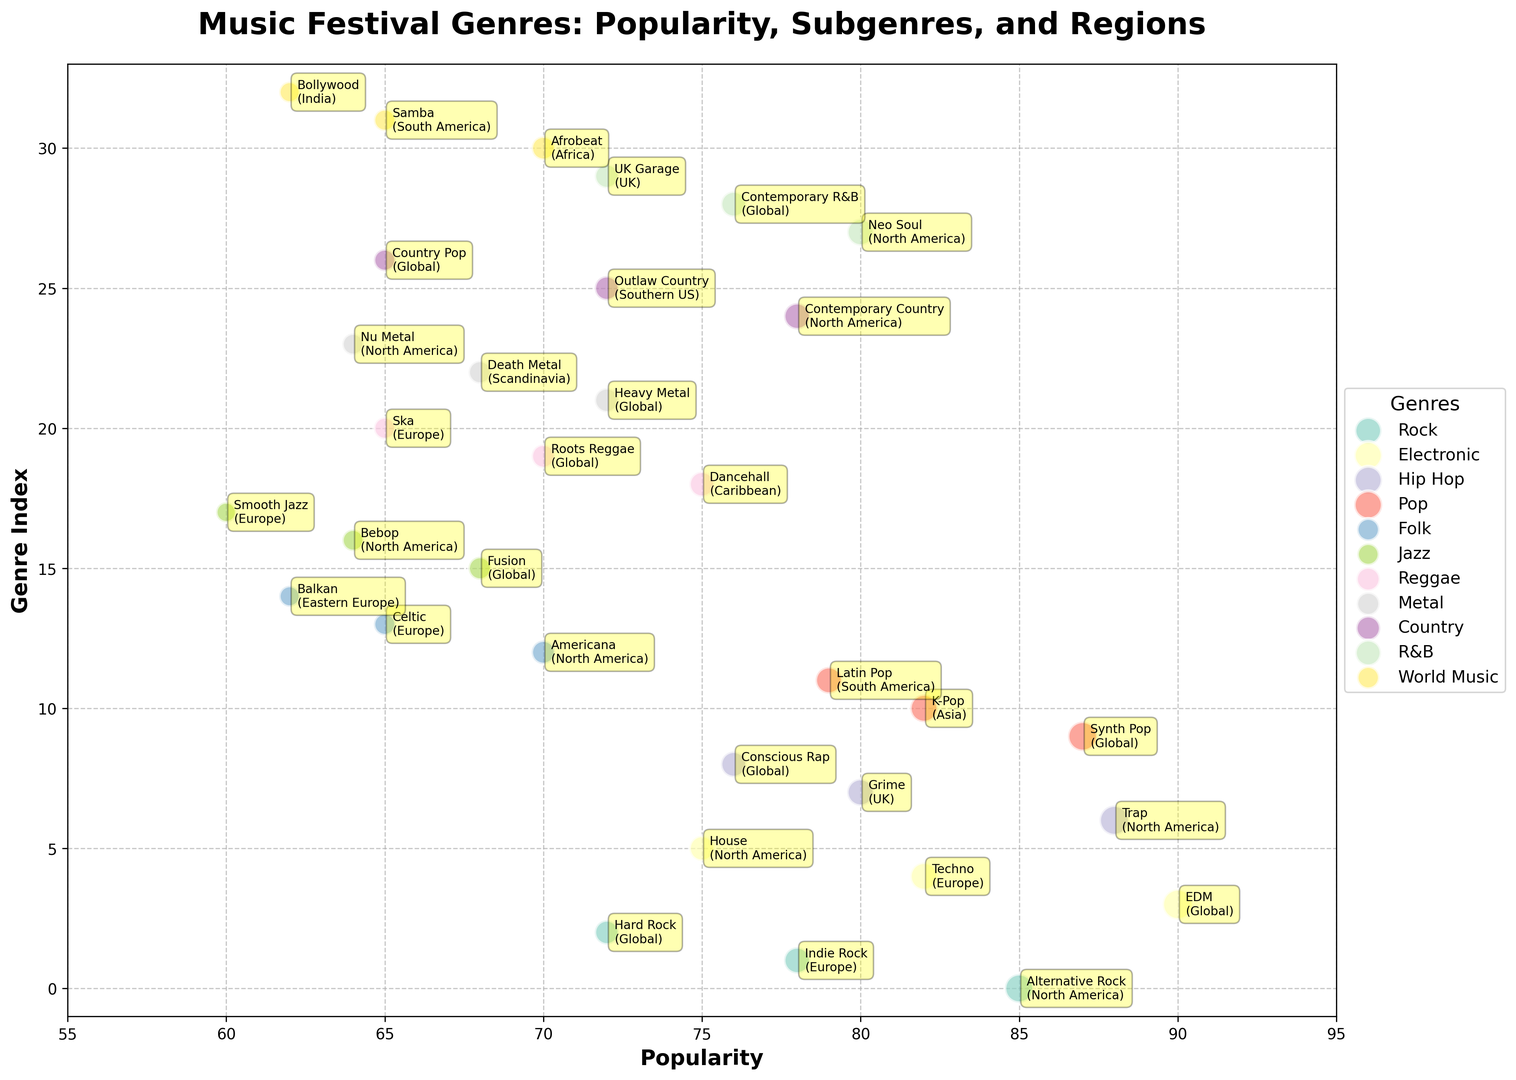Which genre has the highest popularity at festivals? The figure shows several genres with bubbles of varying sizes on the x-axis representing popularity. The highest value for popularity is represented by the largest bubble located farthest to the right. In this case, Electronic music with EDM subgenre has the highest popularity at 90.
Answer: Electronic How does the popularity of Grime (UK) compare with Techno (Europe)? The figure shows different bubbles for subgenres within each genre. Grime has a popularity of 80, while Techno has a popularity of 82. Therefore, Techno is slightly more popular than Grime.
Answer: Techno is more popular How many genres have a popularity above 80? By counting the bubbles on the x-axis that have values greater than 80, we see that Rock, Electronic, Hip Hop, and Pop have values above 80. Counting the unique genres, we get four.
Answer: 4 Which subgenre of Jazz is the least popular? Jazz bubbles can be observed and compared based on their position on the x-axis (popularity). The least popular Jazz subgenre is Smooth Jazz with a popularity of 60.
Answer: Smooth Jazz Compare the popularity of Rock subgenres across different regions. The subgenres of Rock shown include Alternative Rock (85), Indie Rock (78), and Hard Rock (72). Alternative Rock in North America is the most popular, followed by Indie Rock in Europe and then Hard Rock globally.
Answer: Alternative Rock > Indie Rock > Hard Rock What is the popularity difference between Dancehall (Caribbean) and Ska (Europe)? Checking the positions of Dancehall and Ska bubbles on the x-axis, Dancehall has a popularity of 75 while Ska has a popularity of 65. The difference is 75 - 65 = 10.
Answer: 10 Which genres have their most popular subgenres originating in North America? The figure shows the most popular subgenres by region. For North America, the most popular subgenres by genre are Alternative Rock (Rock), Trap (Hip Hop), and Americana (Folk).
Answer: Rock, Hip Hop, Folk What is the average popularity of the Country subgenres? The Country subgenres include Contemporary Country (78), Outlaw Country (72), and Country Pop (65). Calculating the average: (78 + 72 + 65) / 3 = 215 / 3 ≈ 71.67.
Answer: 71.67 Which genre's most popular subgenre is from Asia? The bubble chart shows different regions for subgenres. K-Pop under Pop genre from Asia at a popularity of 82 is higher than any other genre's subgenre from Asia.
Answer: Pop How do the popularity values of World Music subgenres compare? The World Music subgenres and their popularity values are Afrobeat (70), Samba (65), and Bollywood (62). Afrobeat is the most popular, followed by Samba, and then Bollywood.
Answer: Afrobeat > Samba > Bollywood 